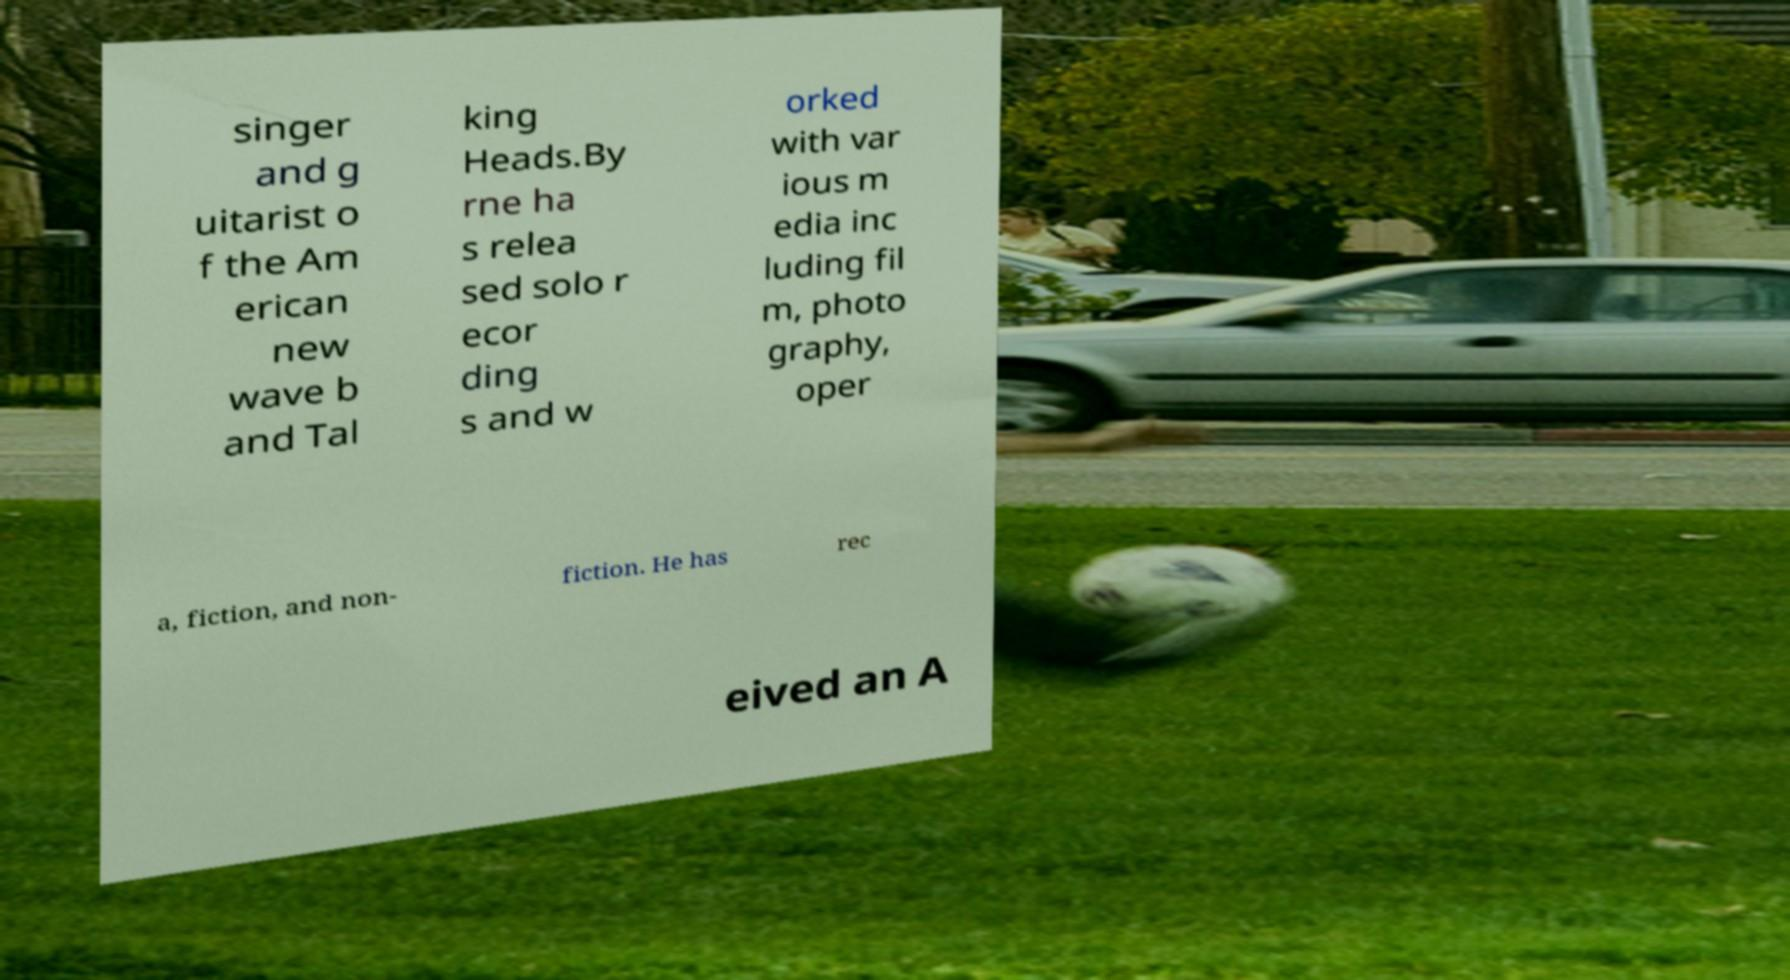What messages or text are displayed in this image? I need them in a readable, typed format. singer and g uitarist o f the Am erican new wave b and Tal king Heads.By rne ha s relea sed solo r ecor ding s and w orked with var ious m edia inc luding fil m, photo graphy, oper a, fiction, and non- fiction. He has rec eived an A 